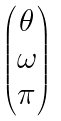<formula> <loc_0><loc_0><loc_500><loc_500>\begin{pmatrix} \theta \\ \omega \\ \pi \end{pmatrix}</formula> 